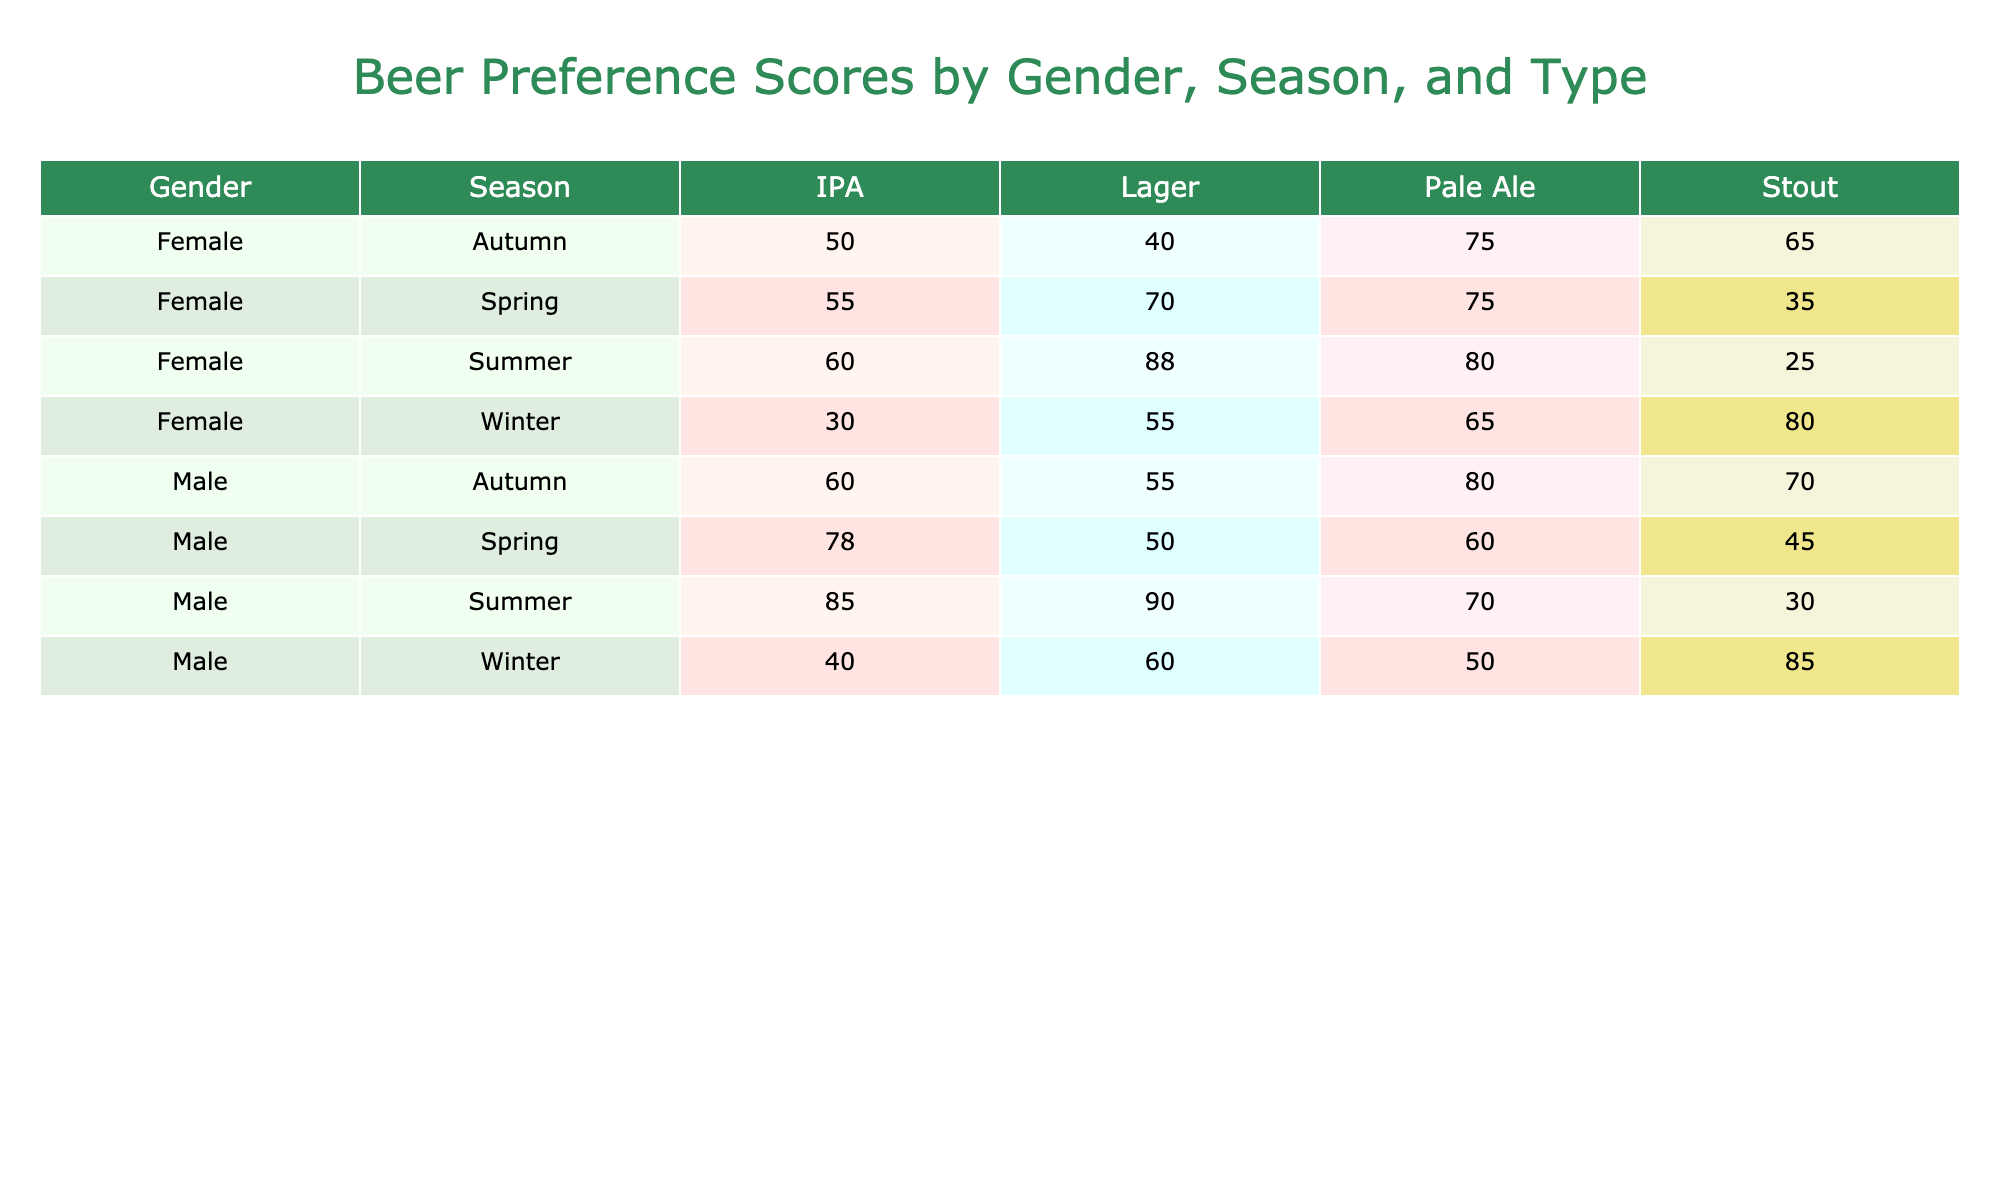What is the preference score for Male IPA in Spring? The table indicates that the preference score for Male IPA in Spring is 78, as this is the value directly corresponding to the Male and Spring categories under the IPA beer type.
Answer: 78 What is the highest preference score for female beer drinkers in summer? Looking at the summer preferences for females, the highest score is for Lager with a preference score of 88. This is determined by comparing the scores for IPA (60), Stout (25), Pale Ale (80), and Lager (88).
Answer: 88 Does the preference score for Male Stout in Winter exceed that of Female Stout in Winter? The preference score for Male Stout in Winter is 85, while for Female Stout in Winter it is 80. Since 85 is greater than 80, the answer is yes.
Answer: Yes What is the average preference score for Pale Ale across all seasons for females? The preference scores for Pale Ale for females in each season are as follows: Spring (75), Summer (80), Autumn (75), and Winter (65). To find the average, we sum these scores (75 + 80 + 75 + 65 = 295) and divide by the number of seasons (4), which gives us an average of 295/4 = 73.75.
Answer: 73.75 Is there a season where Male Lager has a higher score than Female Lager? Examining the scores, Male Lager has preference scores of 50 in Spring, 90 in Summer, 55 in Autumn, and 60 in Winter, while Female Lager has scores of 70 in Spring, 88 in Summer, 40 in Autumn, and 55 in Winter. In Summer, Male Lager's score of 90 exceeds Female Lager's score of 88. Thus, yes, there is a season (Summer).
Answer: Yes What is the total preference score for all beer types for Male drinkers in Autumn? The table lists the preference scores for Male drinkers in Autumn as follows: IPA (60), Stout (70), Pale Ale (80), and Lager (55). Adding these together (60 + 70 + 80 + 55 = 265) gives the total preference score for Male drinkers in Autumn.
Answer: 265 Which beer type had the lowest preference score for Female drinkers in Winter? From the data, the preference scores for Female drinkers in Winter are as follows: IPA (30), Stout (80), Pale Ale (65), and Lager (55). Thus, IPA has the lowest preference score of 30.
Answer: 30 In which season does Male drinkers prefer Stout the most? The preference scores for Male Stout are: Spring (45), Summer (30), Autumn (70), and Winter (85). The highest score is in Winter (85), indicating that Male drinkers prefer Stout the most in Winter.
Answer: Winter What is the difference in preference score between Male and Female for Lager in Summer? For Lager in Summer, the preference score for Males is 90 and for Females, it is 88. The difference is calculated as 90 - 88 = 2. Thus, the difference in preference score between Male and Female for Lager in Summer is 2.
Answer: 2 